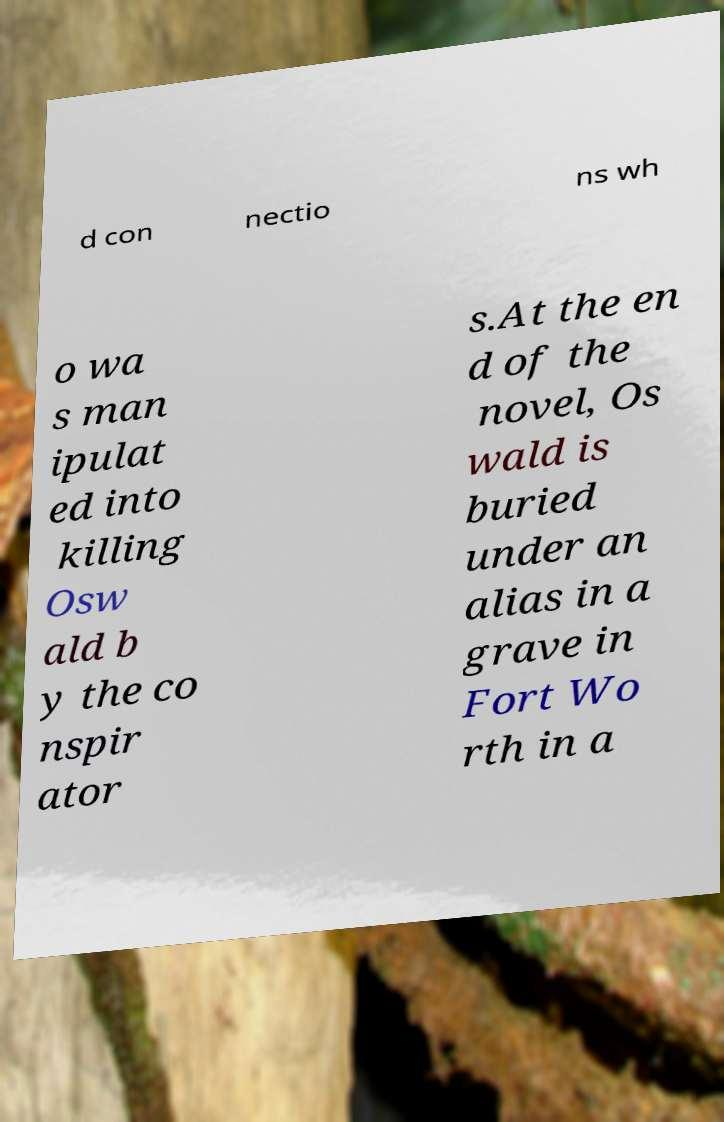I need the written content from this picture converted into text. Can you do that? d con nectio ns wh o wa s man ipulat ed into killing Osw ald b y the co nspir ator s.At the en d of the novel, Os wald is buried under an alias in a grave in Fort Wo rth in a 